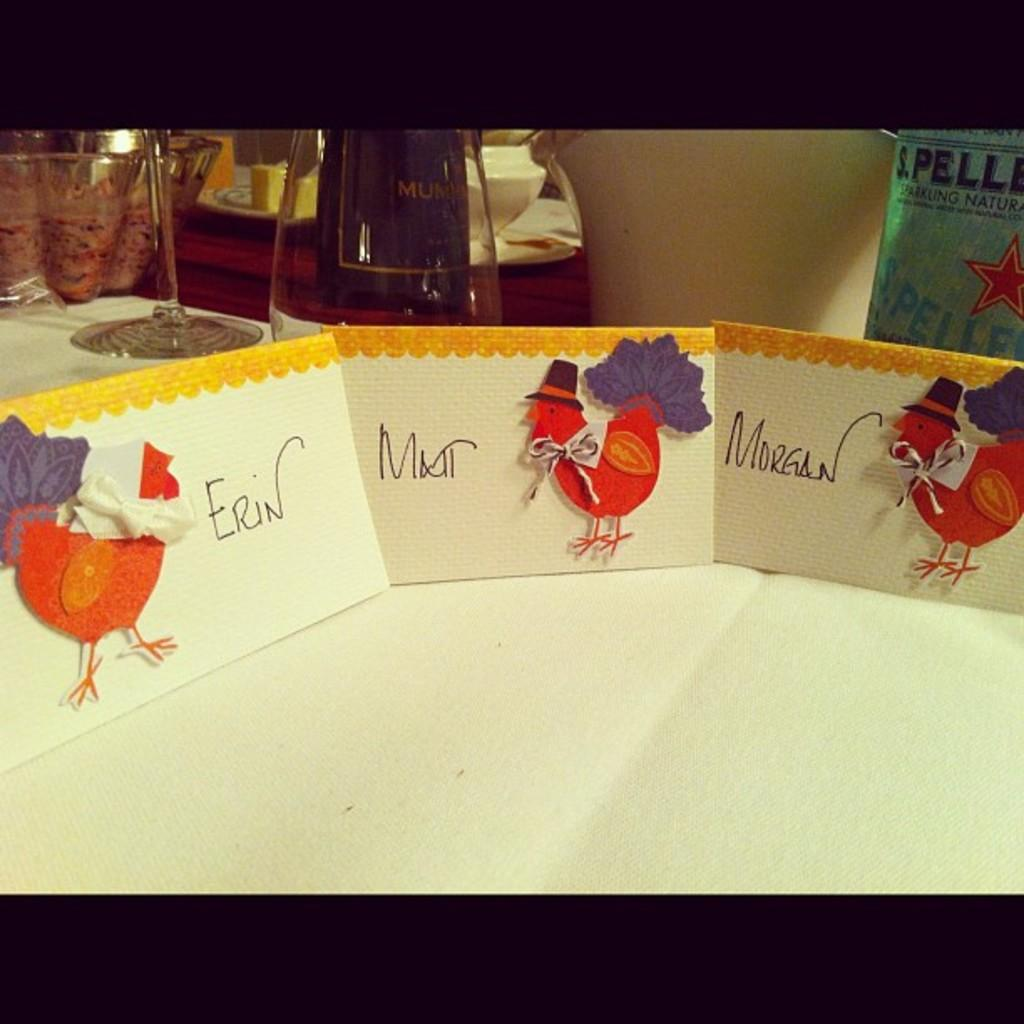<image>
Create a compact narrative representing the image presented. Turkey placecards sit on a table with the names Erin, Matt and Morgan on them 